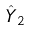<formula> <loc_0><loc_0><loc_500><loc_500>\hat { Y } _ { 2 }</formula> 